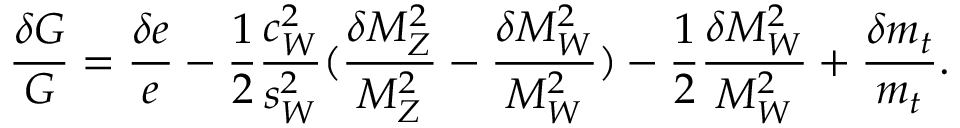Convert formula to latex. <formula><loc_0><loc_0><loc_500><loc_500>{ \frac { \delta G } { G } } = { \frac { \delta e } { e } } - { \frac { 1 } { 2 } } { \frac { c _ { W } ^ { 2 } } { s _ { W } ^ { 2 } } } ( { \frac { \delta M _ { Z } ^ { 2 } } { M _ { Z } ^ { 2 } } } - { \frac { \delta M _ { W } ^ { 2 } } { M _ { W } ^ { 2 } } } ) - { \frac { 1 } { 2 } } { \frac { \delta M _ { W } ^ { 2 } } { M _ { W } ^ { 2 } } } + { \frac { \delta m _ { t } } { m _ { t } } } .</formula> 